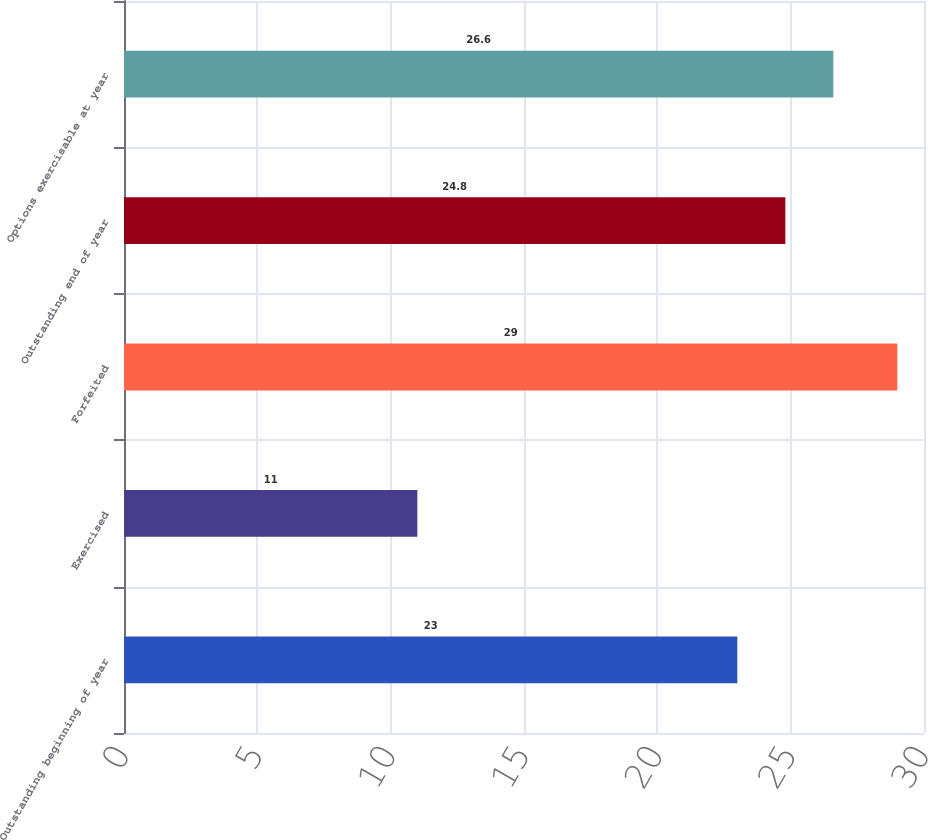Convert chart to OTSL. <chart><loc_0><loc_0><loc_500><loc_500><bar_chart><fcel>Outstanding beginning of year<fcel>Exercised<fcel>Forfeited<fcel>Outstanding end of year<fcel>Options exercisable at year<nl><fcel>23<fcel>11<fcel>29<fcel>24.8<fcel>26.6<nl></chart> 